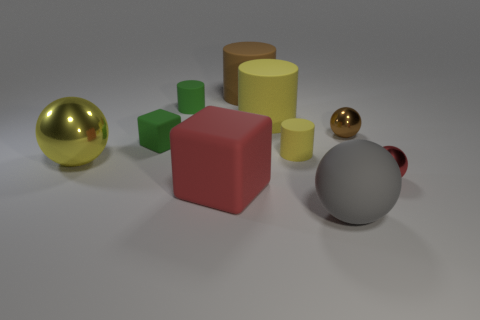Subtract all green cubes. How many cubes are left? 1 Subtract all shiny spheres. How many spheres are left? 1 Subtract all balls. How many objects are left? 6 Subtract 2 cubes. How many cubes are left? 0 Subtract 1 red spheres. How many objects are left? 9 Subtract all red cylinders. Subtract all green spheres. How many cylinders are left? 4 Subtract all purple spheres. How many yellow cubes are left? 0 Subtract all tiny green rubber cylinders. Subtract all large matte balls. How many objects are left? 8 Add 6 tiny brown things. How many tiny brown things are left? 7 Add 6 brown metallic objects. How many brown metallic objects exist? 7 